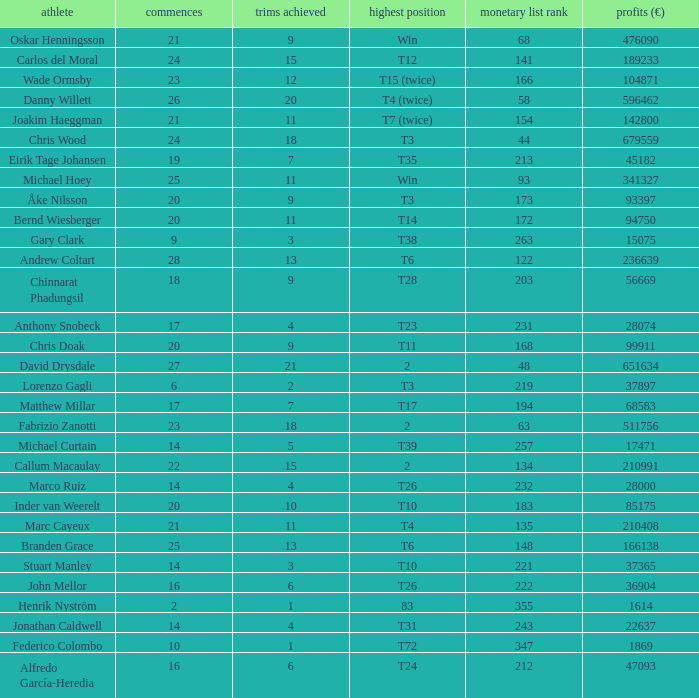Which player made exactly 26 starts? Danny Willett. 